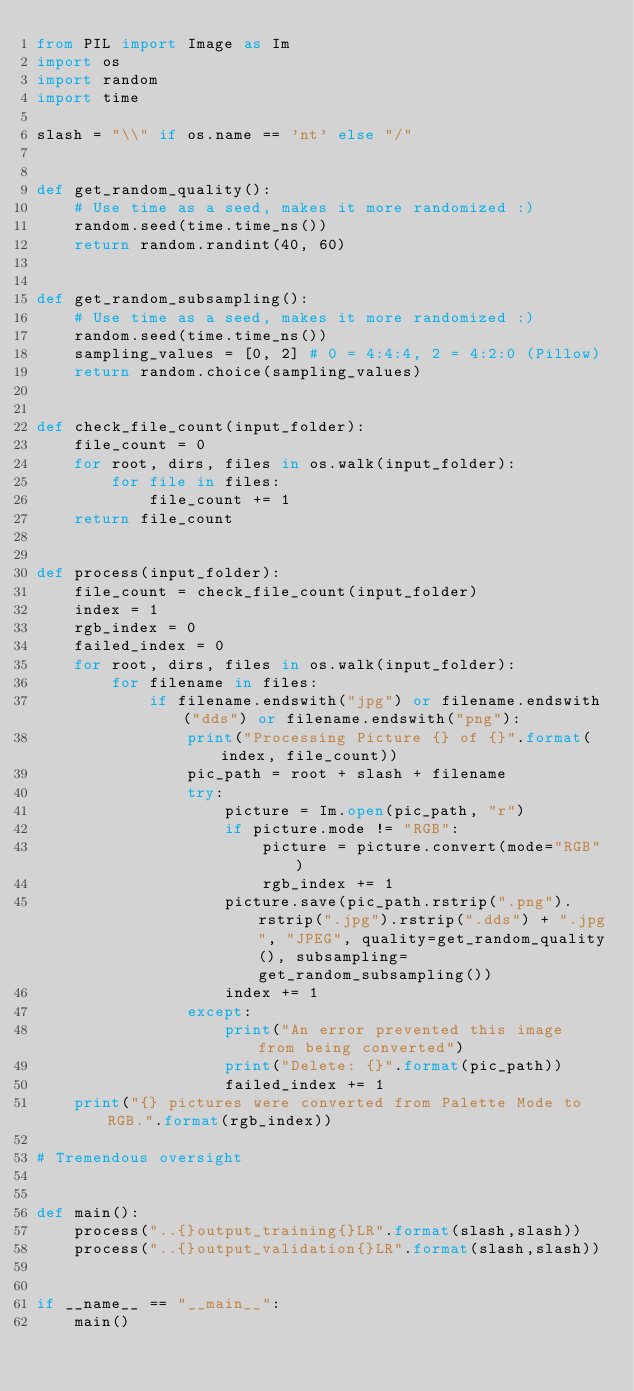Convert code to text. <code><loc_0><loc_0><loc_500><loc_500><_Python_>from PIL import Image as Im
import os
import random
import time

slash = "\\" if os.name == 'nt' else "/"


def get_random_quality():
    # Use time as a seed, makes it more randomized :)
    random.seed(time.time_ns())
    return random.randint(40, 60)


def get_random_subsampling():
    # Use time as a seed, makes it more randomized :)
    random.seed(time.time_ns())
    sampling_values = [0, 2] # 0 = 4:4:4, 2 = 4:2:0 (Pillow)
    return random.choice(sampling_values)


def check_file_count(input_folder):
    file_count = 0
    for root, dirs, files in os.walk(input_folder):
        for file in files:
            file_count += 1
    return file_count


def process(input_folder):
    file_count = check_file_count(input_folder)
    index = 1
    rgb_index = 0
    failed_index = 0
    for root, dirs, files in os.walk(input_folder):
        for filename in files:
            if filename.endswith("jpg") or filename.endswith("dds") or filename.endswith("png"):
                print("Processing Picture {} of {}".format(index, file_count))
                pic_path = root + slash + filename
                try:
                    picture = Im.open(pic_path, "r")
                    if picture.mode != "RGB":
                        picture = picture.convert(mode="RGB")
                        rgb_index += 1
                    picture.save(pic_path.rstrip(".png").rstrip(".jpg").rstrip(".dds") + ".jpg", "JPEG", quality=get_random_quality(), subsampling=get_random_subsampling())
                    index += 1
                except:
                    print("An error prevented this image from being converted")
                    print("Delete: {}".format(pic_path))
                    failed_index += 1
    print("{} pictures were converted from Palette Mode to RGB.".format(rgb_index))

# Tremendous oversight


def main():
    process("..{}output_training{}LR".format(slash,slash))
    process("..{}output_validation{}LR".format(slash,slash))


if __name__ == "__main__":
    main()
</code> 